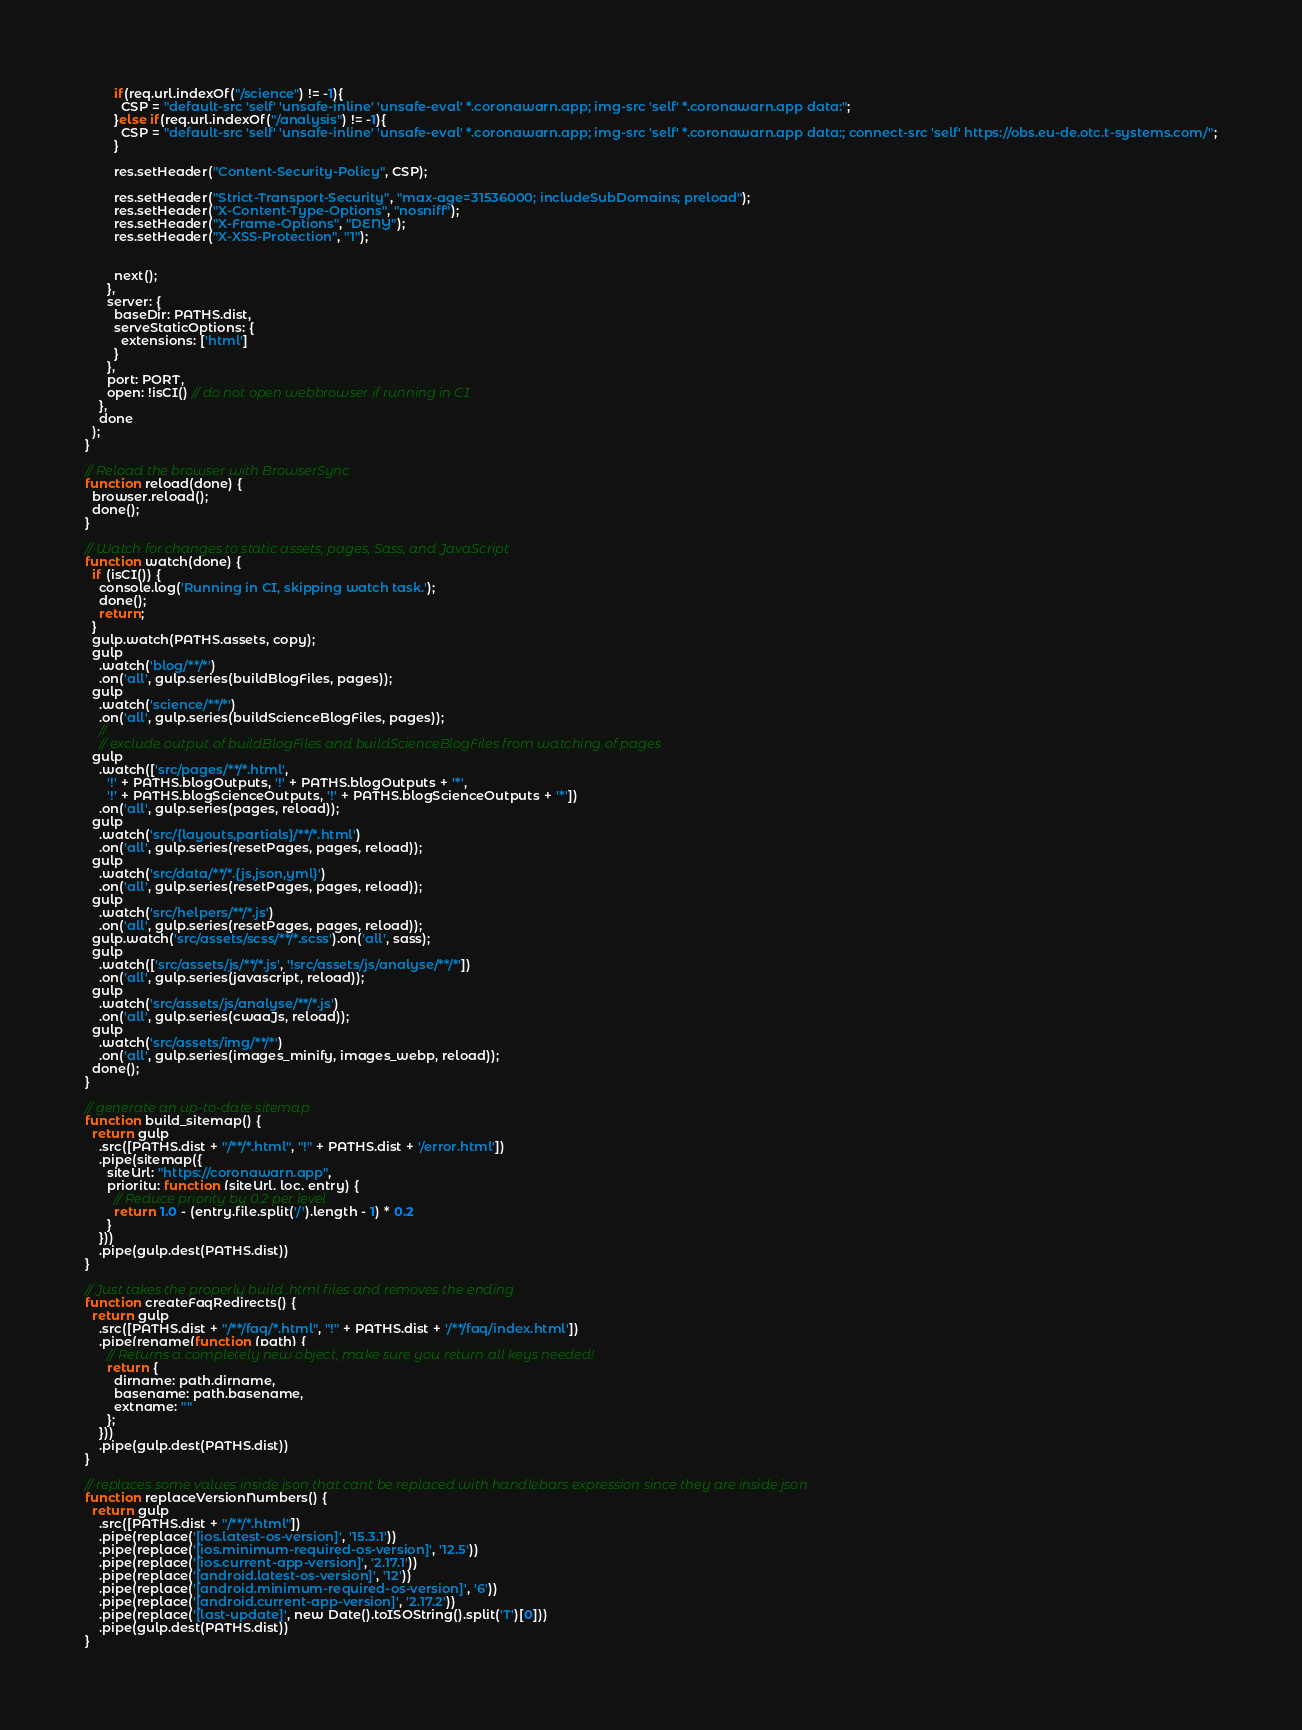<code> <loc_0><loc_0><loc_500><loc_500><_JavaScript_>        if(req.url.indexOf("/science") != -1){
          CSP = "default-src 'self' 'unsafe-inline' 'unsafe-eval' *.coronawarn.app; img-src 'self' *.coronawarn.app data:";
        }else if(req.url.indexOf("/analysis") != -1){
          CSP = "default-src 'self' 'unsafe-inline' 'unsafe-eval' *.coronawarn.app; img-src 'self' *.coronawarn.app data:; connect-src 'self' https://obs.eu-de.otc.t-systems.com/";
        }

        res.setHeader("Content-Security-Policy", CSP);

        res.setHeader("Strict-Transport-Security", "max-age=31536000; includeSubDomains; preload");
        res.setHeader("X-Content-Type-Options", "nosniff");
        res.setHeader("X-Frame-Options", "DENY");
        res.setHeader("X-XSS-Protection", "1");
        

        next();
      },
      server: {
        baseDir: PATHS.dist,
        serveStaticOptions: {
          extensions: ['html']
        }
      },
      port: PORT,
      open: !isCI() // do not open webbrowser if running in CI
    },
    done
  );
}

// Reload the browser with BrowserSync
function reload(done) {
  browser.reload();
  done();
}

// Watch for changes to static assets, pages, Sass, and JavaScript
function watch(done) {
  if (isCI()) {
    console.log('Running in CI, skipping watch task.');
    done();
    return;
  }
  gulp.watch(PATHS.assets, copy);
  gulp
    .watch('blog/**/*')
    .on('all', gulp.series(buildBlogFiles, pages));
  gulp
    .watch('science/**/*')
    .on('all', gulp.series(buildScienceBlogFiles, pages));  
    //
    // exclude output of buildBlogFiles and buildScienceBlogFiles from watching of pages
  gulp
    .watch(['src/pages/**/*.html',
      '!' + PATHS.blogOutputs, '!' + PATHS.blogOutputs + '*',
      '!' + PATHS.blogScienceOutputs, '!' + PATHS.blogScienceOutputs + '*'])
    .on('all', gulp.series(pages, reload));
  gulp
    .watch('src/{layouts,partials}/**/*.html')
    .on('all', gulp.series(resetPages, pages, reload));
  gulp
    .watch('src/data/**/*.{js,json,yml}')
    .on('all', gulp.series(resetPages, pages, reload));
  gulp
    .watch('src/helpers/**/*.js')
    .on('all', gulp.series(resetPages, pages, reload));
  gulp.watch('src/assets/scss/**/*.scss').on('all', sass);
  gulp
    .watch(['src/assets/js/**/*.js', '!src/assets/js/analyse/**/*'])
    .on('all', gulp.series(javascript, reload));
  gulp
    .watch('src/assets/js/analyse/**/*.js')
    .on('all', gulp.series(cwaaJs, reload));
  gulp
    .watch('src/assets/img/**/*')
    .on('all', gulp.series(images_minify, images_webp, reload));
  done();
}

// generate an up-to-date sitemap
function build_sitemap() {
  return gulp
    .src([PATHS.dist + "/**/*.html", "!" + PATHS.dist + '/error.html'])
    .pipe(sitemap({
      siteUrl: "https://coronawarn.app",
      priority: function (siteUrl, loc, entry) {
        // Reduce priority by 0.2 per level
        return 1.0 - (entry.file.split('/').length - 1) * 0.2
      }
    }))
    .pipe(gulp.dest(PATHS.dist))
}

// Just takes the properly build .html files and removes the ending
function createFaqRedirects() {
  return gulp
    .src([PATHS.dist + "/**/faq/*.html", "!" + PATHS.dist + '/**/faq/index.html'])
    .pipe(rename(function (path) {
      // Returns a completely new object, make sure you return all keys needed!
      return {
        dirname: path.dirname,
        basename: path.basename,
        extname: ""
      };
    }))
    .pipe(gulp.dest(PATHS.dist))
}

// replaces some values inside json that cant be replaced with handlebars expression since they are inside json
function replaceVersionNumbers() {
  return gulp
    .src([PATHS.dist + "/**/*.html"])
    .pipe(replace('[ios.latest-os-version]', '15.3.1'))
    .pipe(replace('[ios.minimum-required-os-version]', '12.5'))
    .pipe(replace('[ios.current-app-version]', '2.17.1'))
    .pipe(replace('[android.latest-os-version]', '12'))
    .pipe(replace('[android.minimum-required-os-version]', '6'))
    .pipe(replace('[android.current-app-version]', '2.17.2'))
    .pipe(replace('[last-update]', new Date().toISOString().split('T')[0]))
    .pipe(gulp.dest(PATHS.dist))
}
</code> 